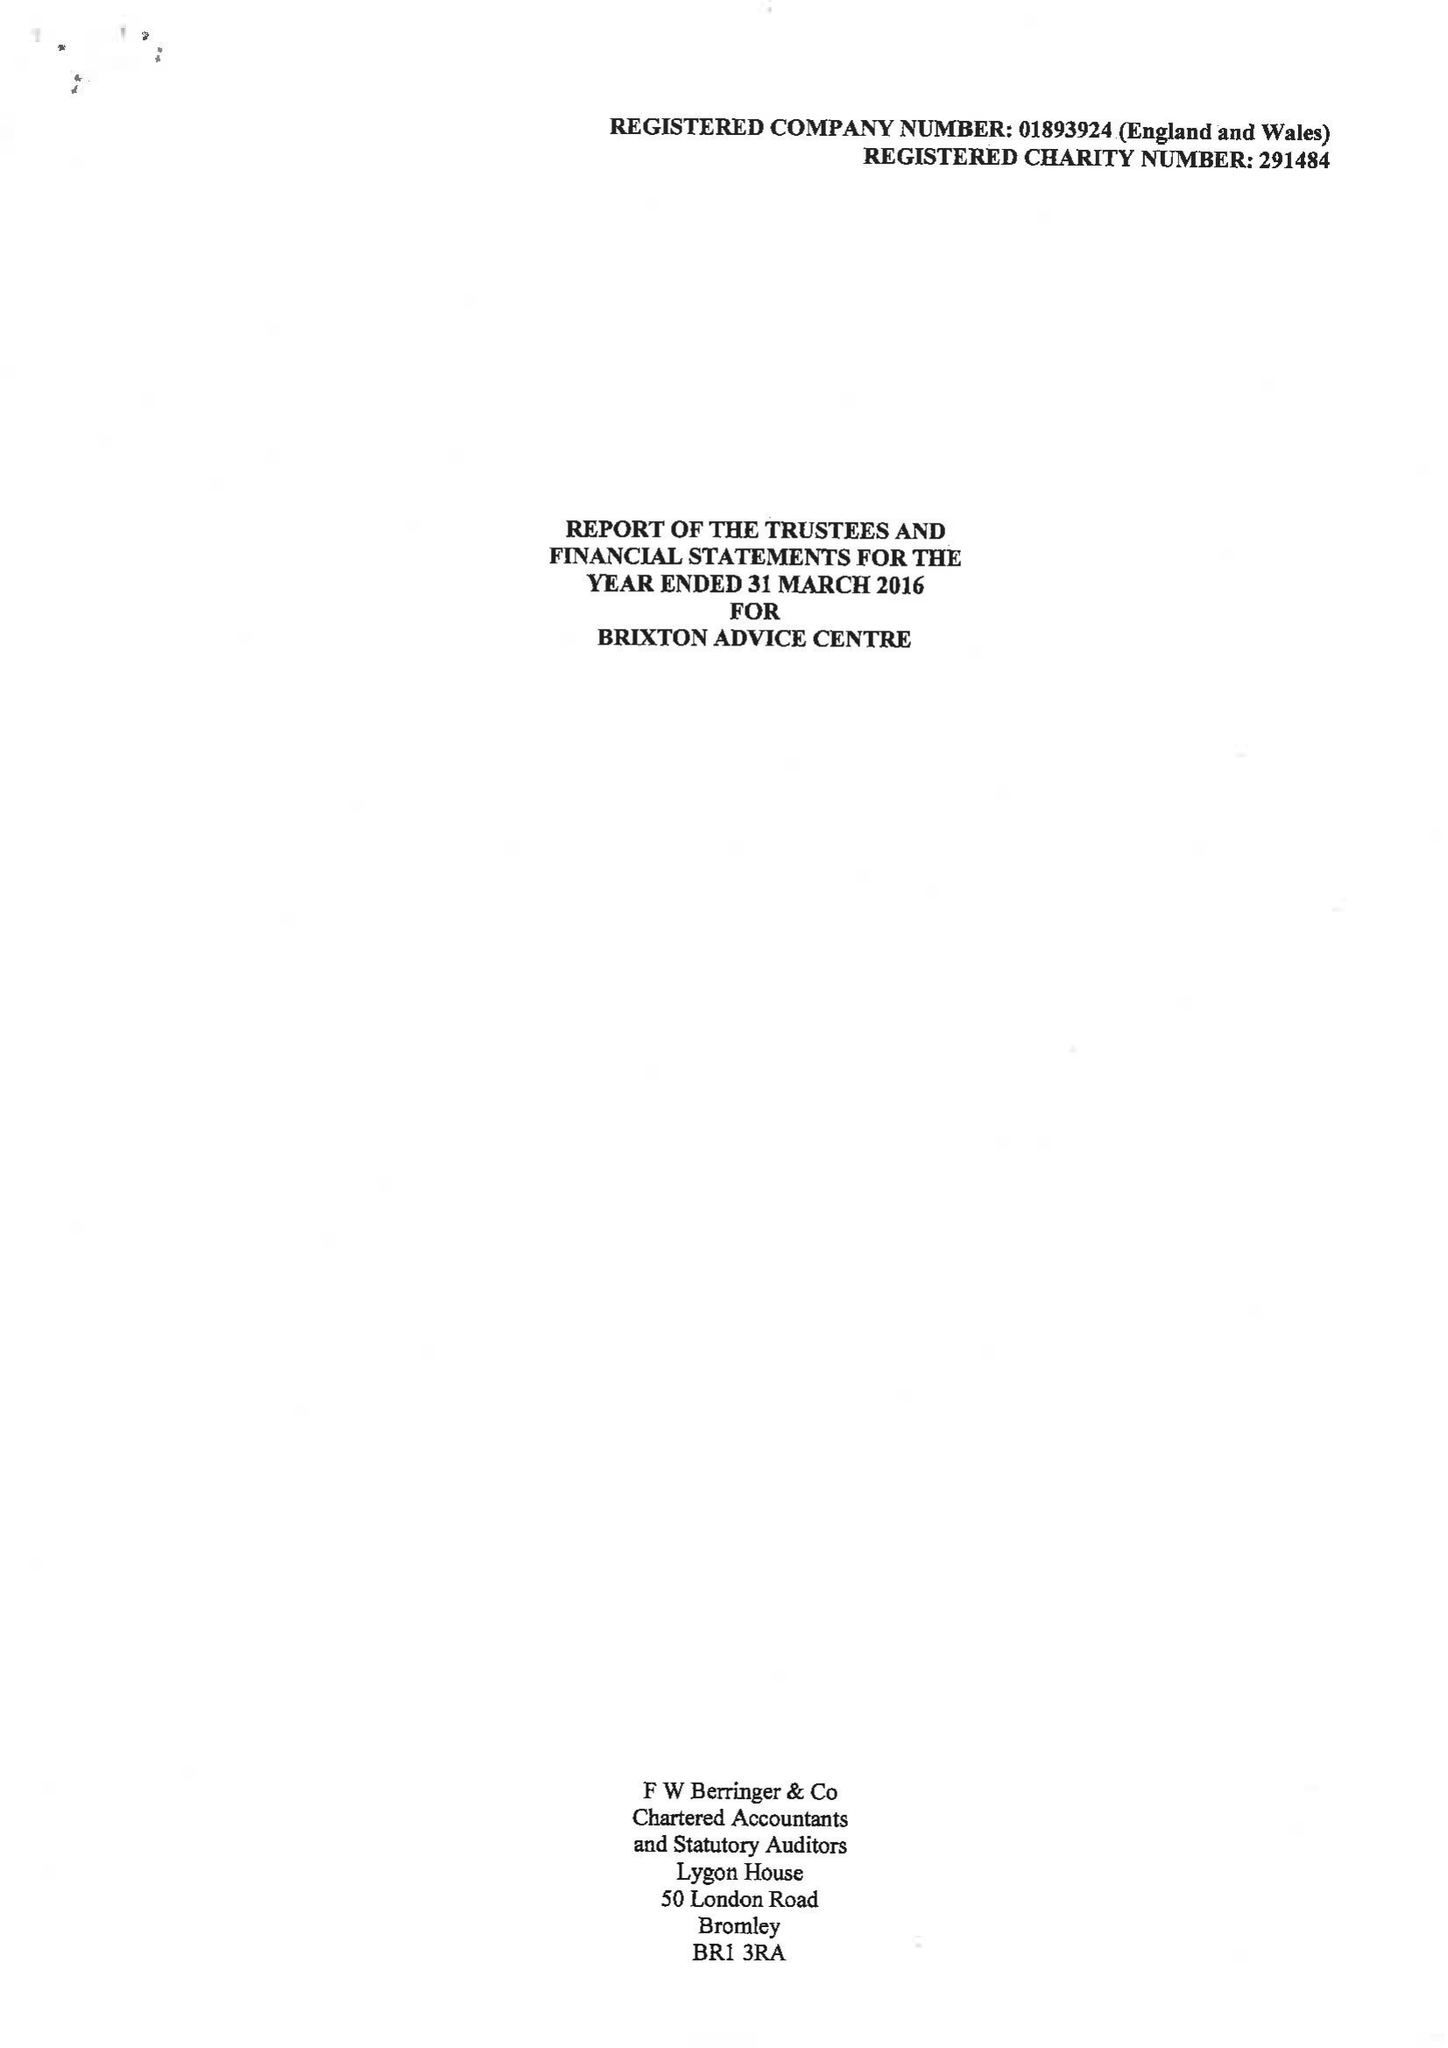What is the value for the address__postcode?
Answer the question using a single word or phrase. SE24 0LU 